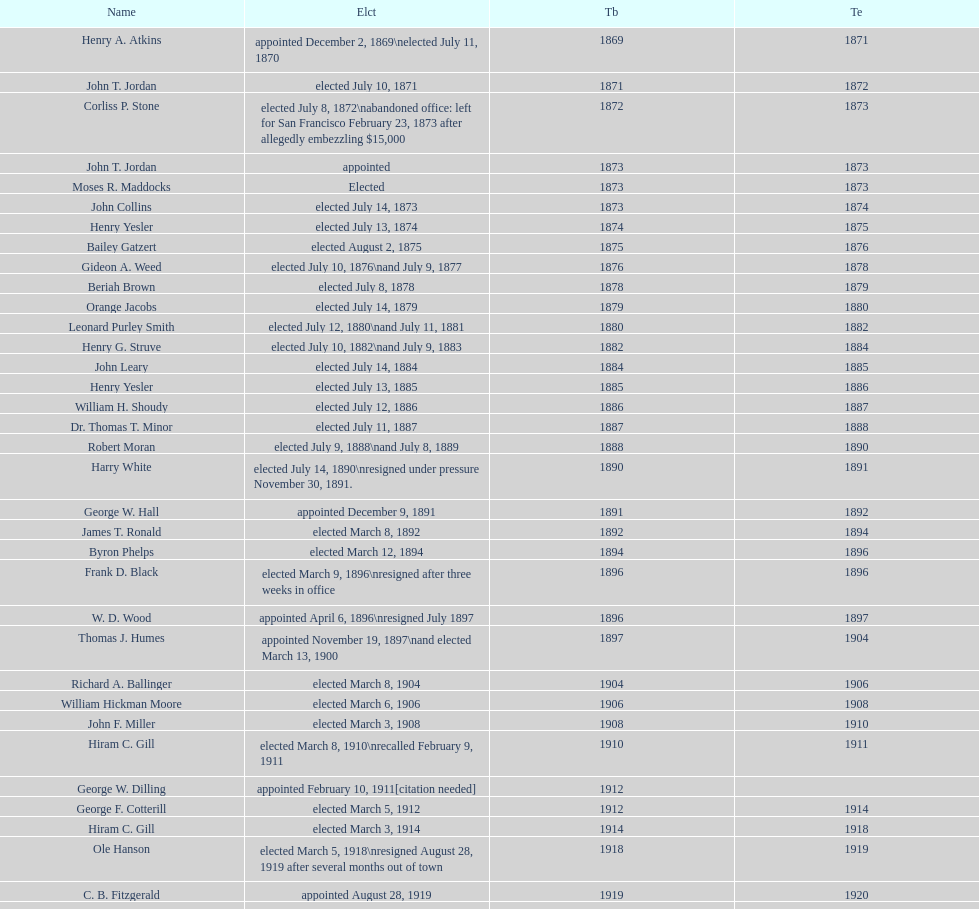Who was mayor of seattle, washington before being appointed to department of transportation during the nixon administration? James d'Orma Braman. 